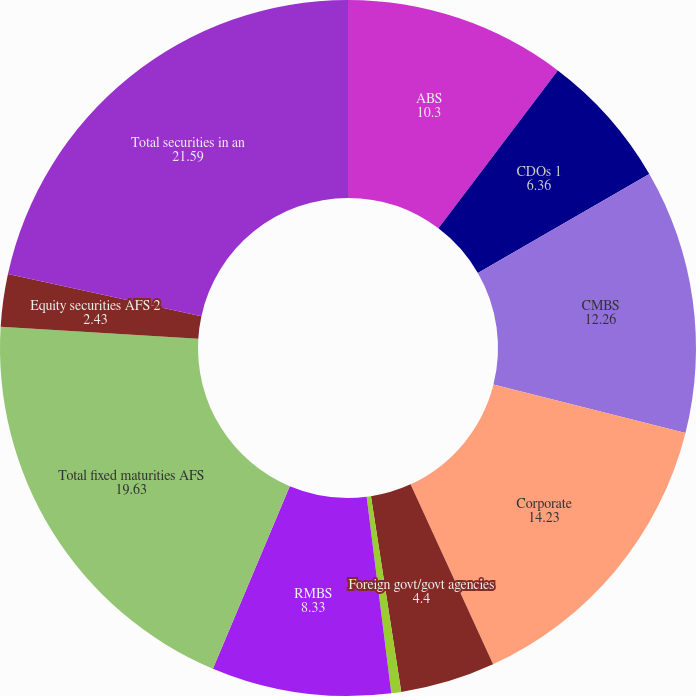Convert chart. <chart><loc_0><loc_0><loc_500><loc_500><pie_chart><fcel>ABS<fcel>CDOs 1<fcel>CMBS<fcel>Corporate<fcel>Foreign govt/govt agencies<fcel>Municipal<fcel>RMBS<fcel>Total fixed maturities AFS<fcel>Equity securities AFS 2<fcel>Total securities in an<nl><fcel>10.3%<fcel>6.36%<fcel>12.26%<fcel>14.23%<fcel>4.4%<fcel>0.46%<fcel>8.33%<fcel>19.63%<fcel>2.43%<fcel>21.59%<nl></chart> 